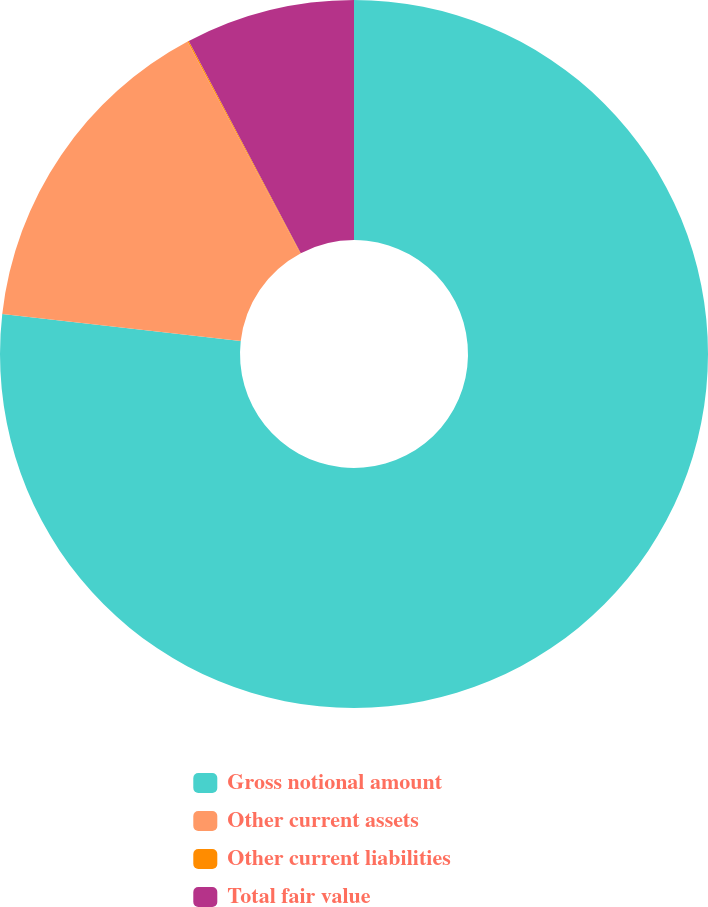Convert chart to OTSL. <chart><loc_0><loc_0><loc_500><loc_500><pie_chart><fcel>Gross notional amount<fcel>Other current assets<fcel>Other current liabilities<fcel>Total fair value<nl><fcel>76.81%<fcel>15.41%<fcel>0.06%<fcel>7.73%<nl></chart> 